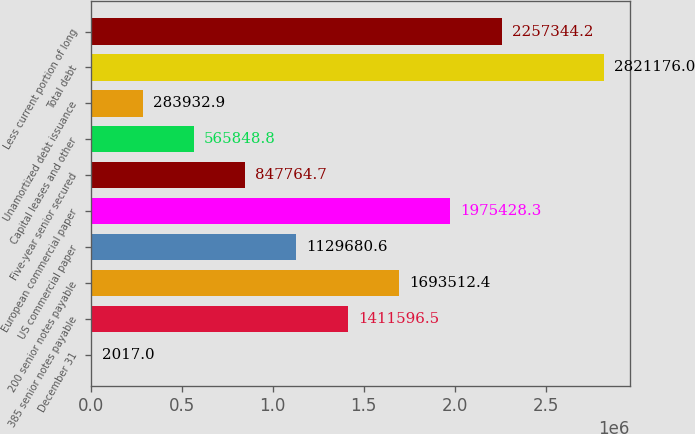Convert chart. <chart><loc_0><loc_0><loc_500><loc_500><bar_chart><fcel>December 31<fcel>385 senior notes payable<fcel>200 senior notes payable<fcel>US commercial paper<fcel>European commercial paper<fcel>Five-year senior secured<fcel>Capital leases and other<fcel>Unamortized debt issuance<fcel>Total debt<fcel>Less current portion of long<nl><fcel>2017<fcel>1.4116e+06<fcel>1.69351e+06<fcel>1.12968e+06<fcel>1.97543e+06<fcel>847765<fcel>565849<fcel>283933<fcel>2.82118e+06<fcel>2.25734e+06<nl></chart> 